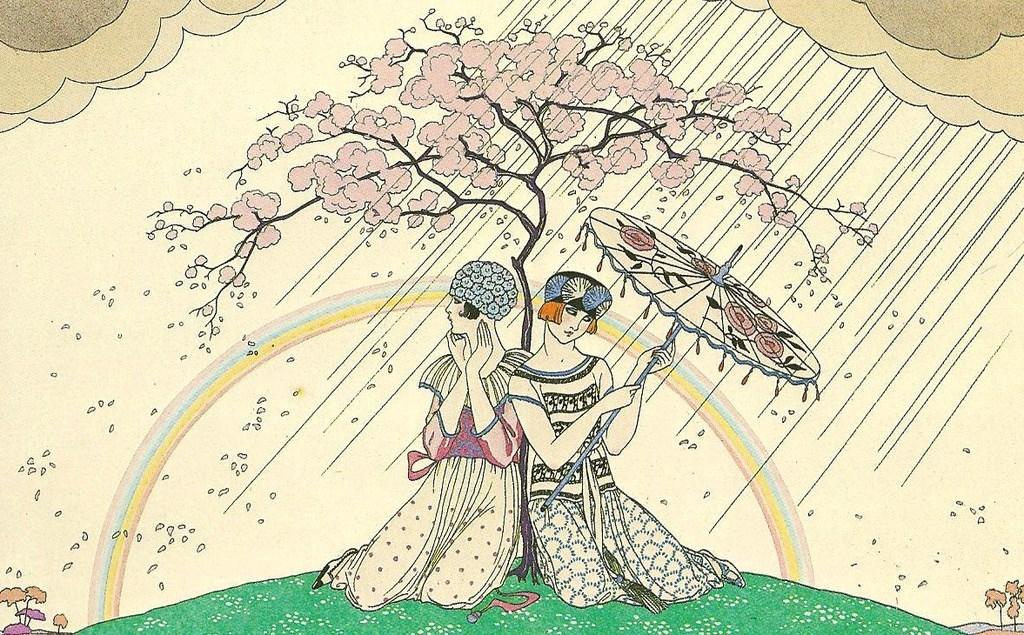How would you summarize this image in a sentence or two? This is a painting. In this painting, we can see there are two women sitting on the grass on the ground. One of them is holding an umbrella. Behind them, there is a tree. In the background, there are trees, mountains, water drops, a rainbow and there are clouds in the sky. 